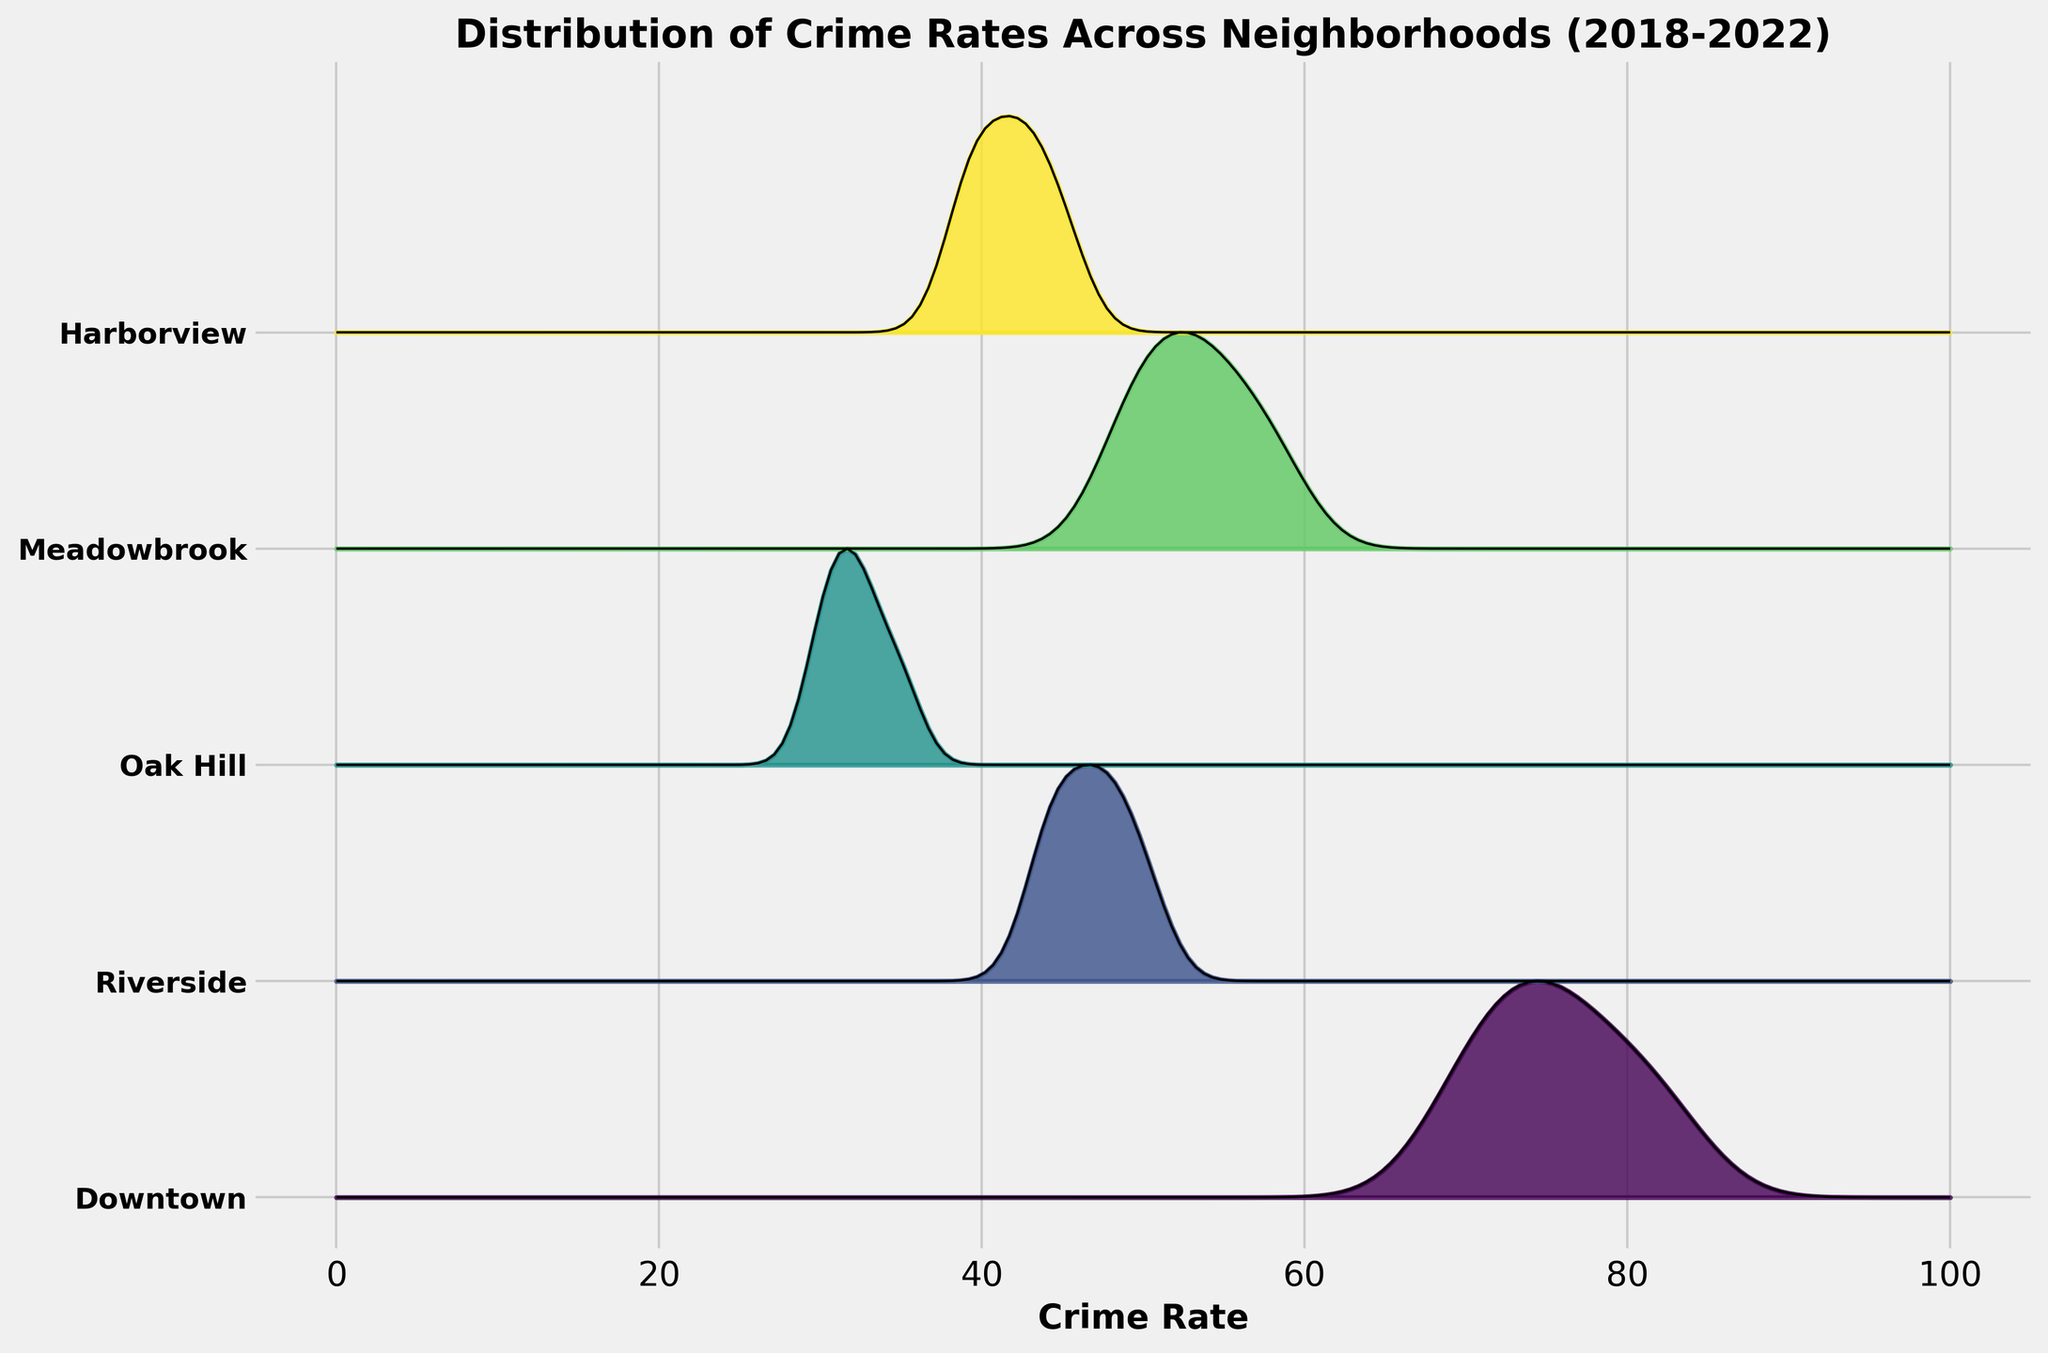what is the title of the figure The title is written at the top of the figure. It helps in understanding the main theme or subject of the plot.
Answer: Distribution of Crime Rates Across Neighborhoods (2018-2022) How many neighborhoods are represented in the figure? Count the number of labels on the y-axis, each representing a different neighborhood.
Answer: 5 Which neighborhood appears to have the highest crime rates? Look for the neighborhood with the ridgeline plot extending farthest to the right on the x-axis, representing higher crime rates.
Answer: Downtown Which neighborhood's crime rate shows a clear decreasing trend over the years? Observe the change in the position and spread of the ridgeline plots for each neighborhood. The neighborhood with ridgeline plots shifting to the left over time shows a decreasing trend.
Answer: Downtown What colors represent the different neighborhoods? Identify the distinct colors used in the ridgeline plot for each neighborhood.
Answer: Variations of blue, green, and yellow What is the approximate range of crime rates for Meadowbrook? Look at the spread of the ridgeline plot for Meadowbrook along the x-axis to determine the minimum and maximum values.
Answer: 49-58 Which neighborhood has the narrowest distribution of crime rates? Look for the ridgeline plot with the least spread along the x-axis.
Answer: Oak Hill Compare the crime rate trends of Harborview and Riverside. Which one is more stable over time? Check the shifts and spread in the ridgeline plots for Harborview and Riverside. The one with less movement or change indicates more stability.
Answer: Harborview Does any neighborhood show an increasing trend in crime rates over the years? If so, which one? Look for neighborhoods where the ridgeline plots are moving towards the right on the x-axis over time.
Answer: Riverside What can you infer about the crime rate trends in Oak Hill from 2018 to 2022? By observing the ridgeline plot for Oak Hill, see if the plots are stable, increasing, or decreasing.
Answer: Slightly increasing and then stabilizing 